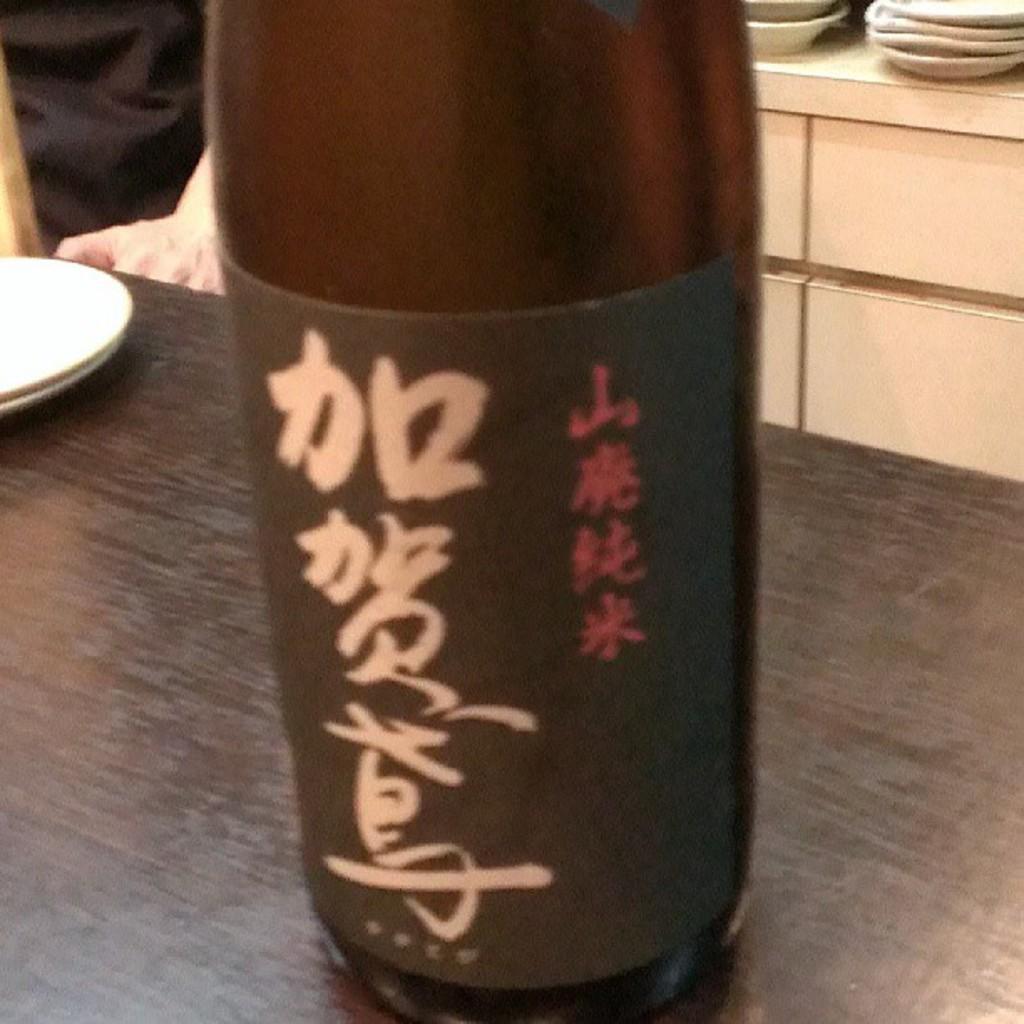Could you give a brief overview of what you see in this image? In this image we can see a bottle which is of brown color is on table and at the background of the image there is a person wearing black color dress standing, there are some plates. 